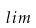<formula> <loc_0><loc_0><loc_500><loc_500>l i m</formula> 